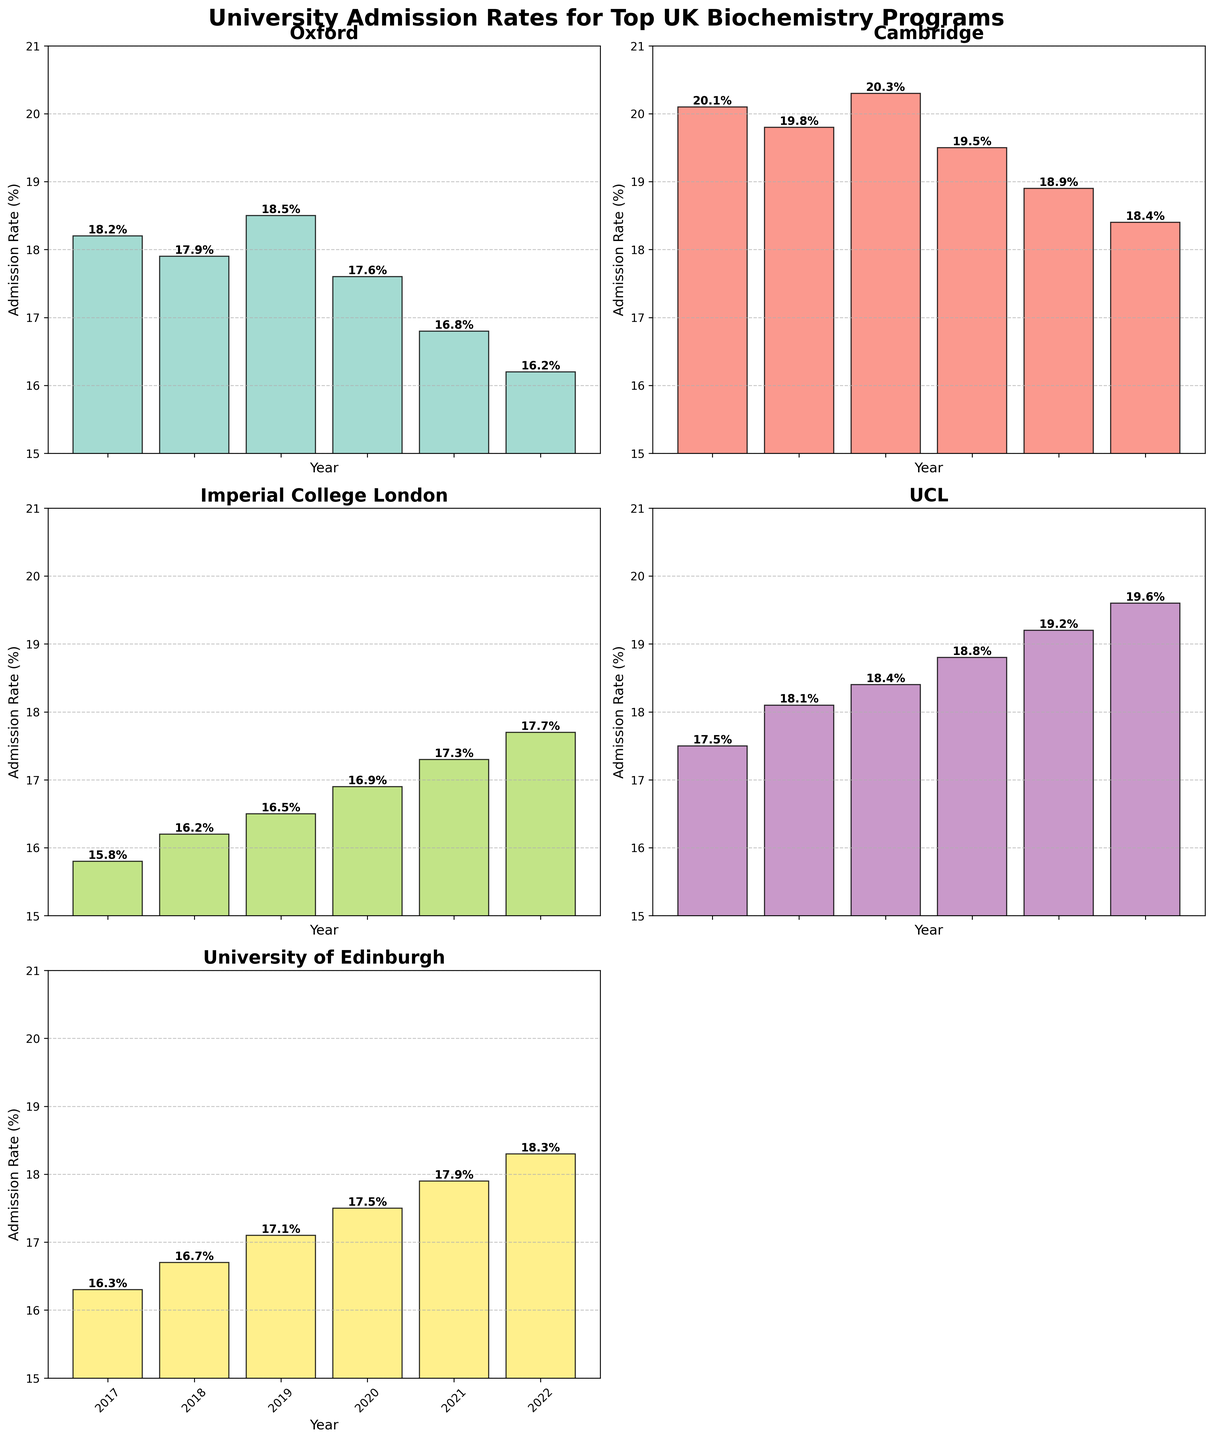Which university exhibited the highest admission rate in 2021? Look at the bar chart for the year 2021 across all universities and find the tallest bar. Cambridge had the tallest bar with an admission rate of 18.9%.
Answer: Cambridge How did the admission rate for Oxford change from 2017 to 2022? Identify the heights of the bars for Oxford in 2017 and 2022, then compare them. In 2017, Oxford had 18.2%, and in 2022, it had 16.2%. This represents a decrease of 2%.
Answer: Decreased by 2% What is the average admission rate for Imperial College London from 2017 to 2022? Sum up the admission rates for Imperial College London from each year and divide by the number of years (6). (15.8 + 16.2 + 16.5 + 16.9 + 17.3 + 17.7) / 6 = 16.4%.
Answer: 16.4% Which university had the most significant change in admission rates between 2017 and 2022? Calculate the difference between the 2017 and 2022 admission rates for each university. Oxford: 2%, Cambridge: 1.7%, Imperial College London: 1.9%, UCL: 2.1%, University of Edinburgh: 2%. UCL had the most significant change, 2.1%.
Answer: UCL Is the admission rate trend for UCL increasing or decreasing? Observe the bars for UCL from 2017 to 2022. The bars increase in height over time, indicating an increasing trend.
Answer: Increasing Between Oxford and Cambridge, which university consistently had higher admission rates each year? Compare the heights of the bars for Oxford and Cambridge for each year from 2017 to 2022. Cambridge's bars were consistently taller each year, indicating a higher admission rate.
Answer: Cambridge What is the cumulative admission rate of University of Edinburgh over all the years? Add up the admission rates for University of Edinburgh from 2017 to 2022. 16.3 + 16.7 + 17.1 + 17.5 + 17.9 + 18.3 = 103.8%.
Answer: 103.8% Which university had the smallest variation in admission rates over the period 2017 to 2022? Calculate the range (max value - min value) of the admission rates for each university. Oxford: 2.3%, Cambridge: 1.9%, Imperial College London: 1.9%, UCL: 2.1%, University of Edinburgh: 2%. Both Cambridge and Imperial College London had the smallest variation of 1.9%.
Answer: Cambridge and Imperial College London 